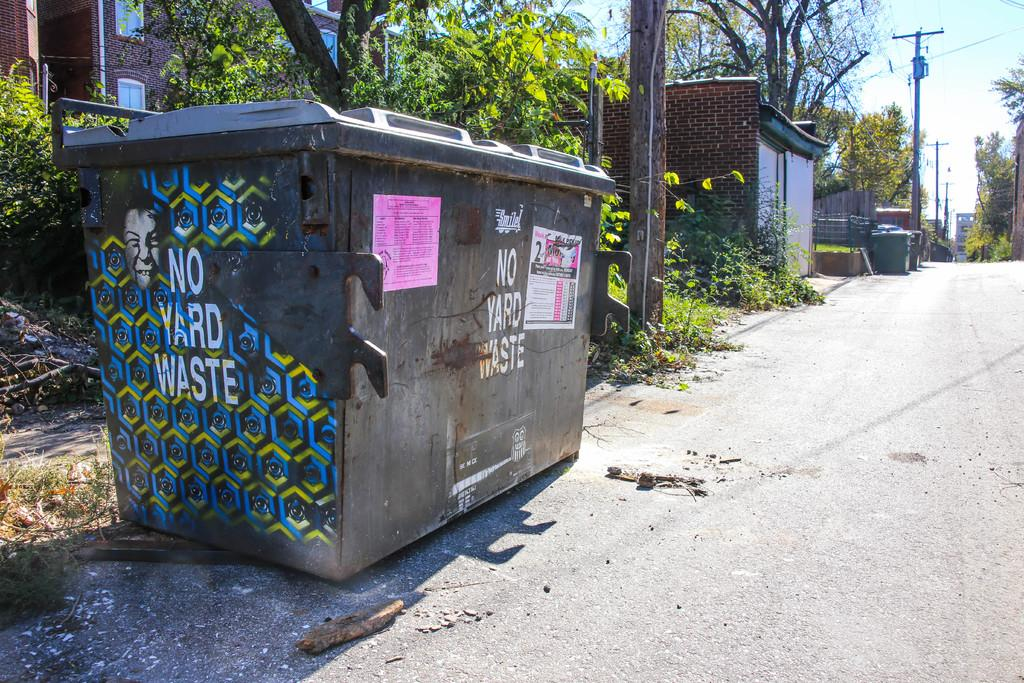<image>
Write a terse but informative summary of the picture. A trash bin says "NO YARD WASTE" on the front and side. 